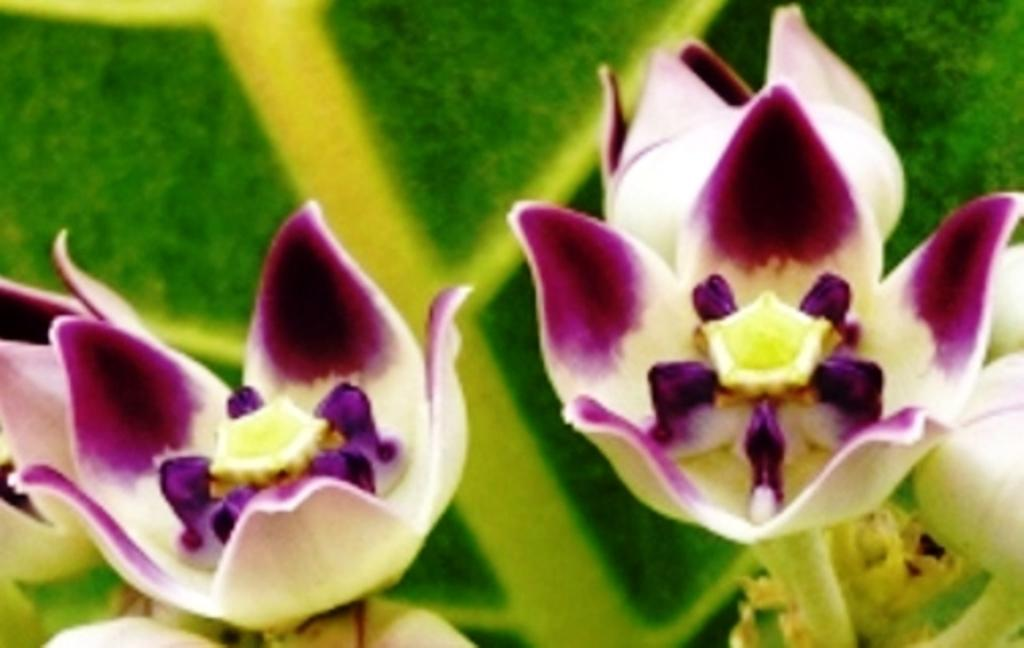What type of living organisms can be seen in the image? There are flowers in the image. Can you describe the background of the image? In the background, there is an object or area with green and yellow colors. What type of dress is the crook wearing in the image? There is no crook or dress present in the image; it only features flowers and a background with green and yellow colors. 